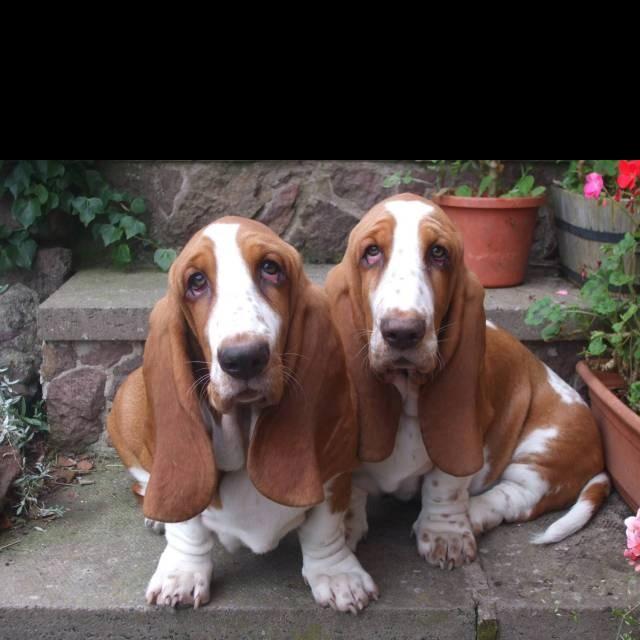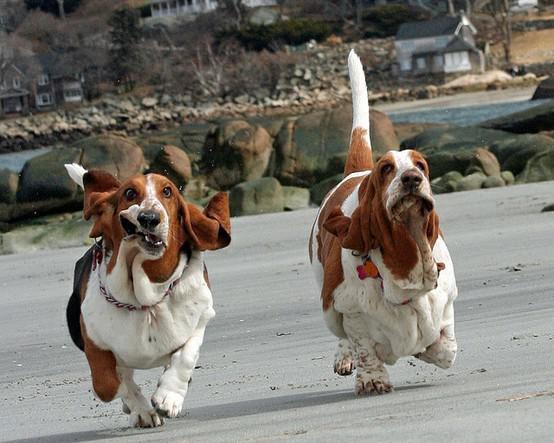The first image is the image on the left, the second image is the image on the right. Assess this claim about the two images: "All dogs are in the grass.". Correct or not? Answer yes or no. No. 